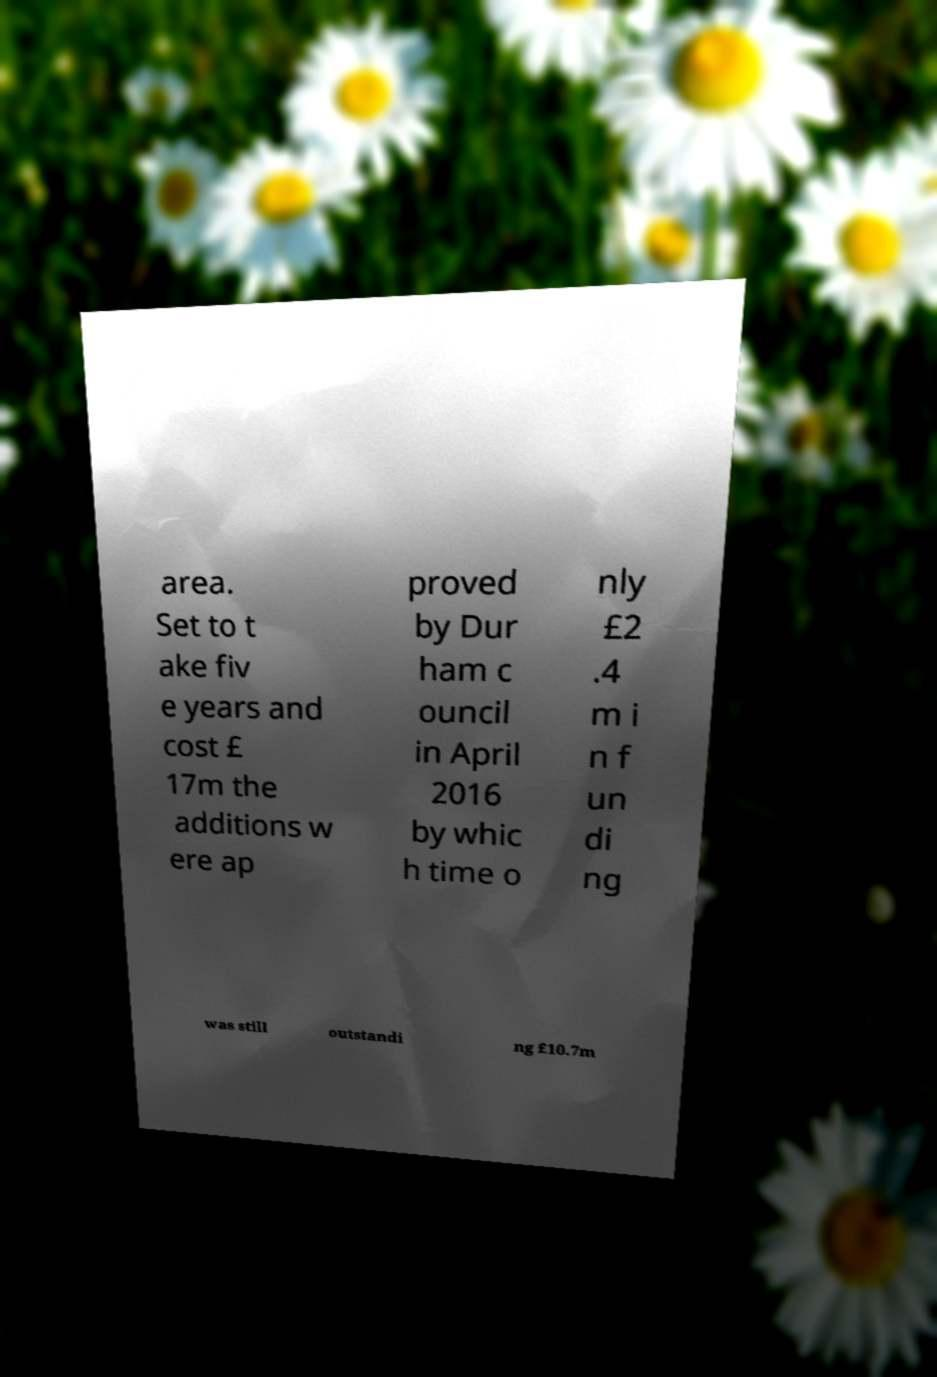What messages or text are displayed in this image? I need them in a readable, typed format. area. Set to t ake fiv e years and cost £ 17m the additions w ere ap proved by Dur ham c ouncil in April 2016 by whic h time o nly £2 .4 m i n f un di ng was still outstandi ng £10.7m 